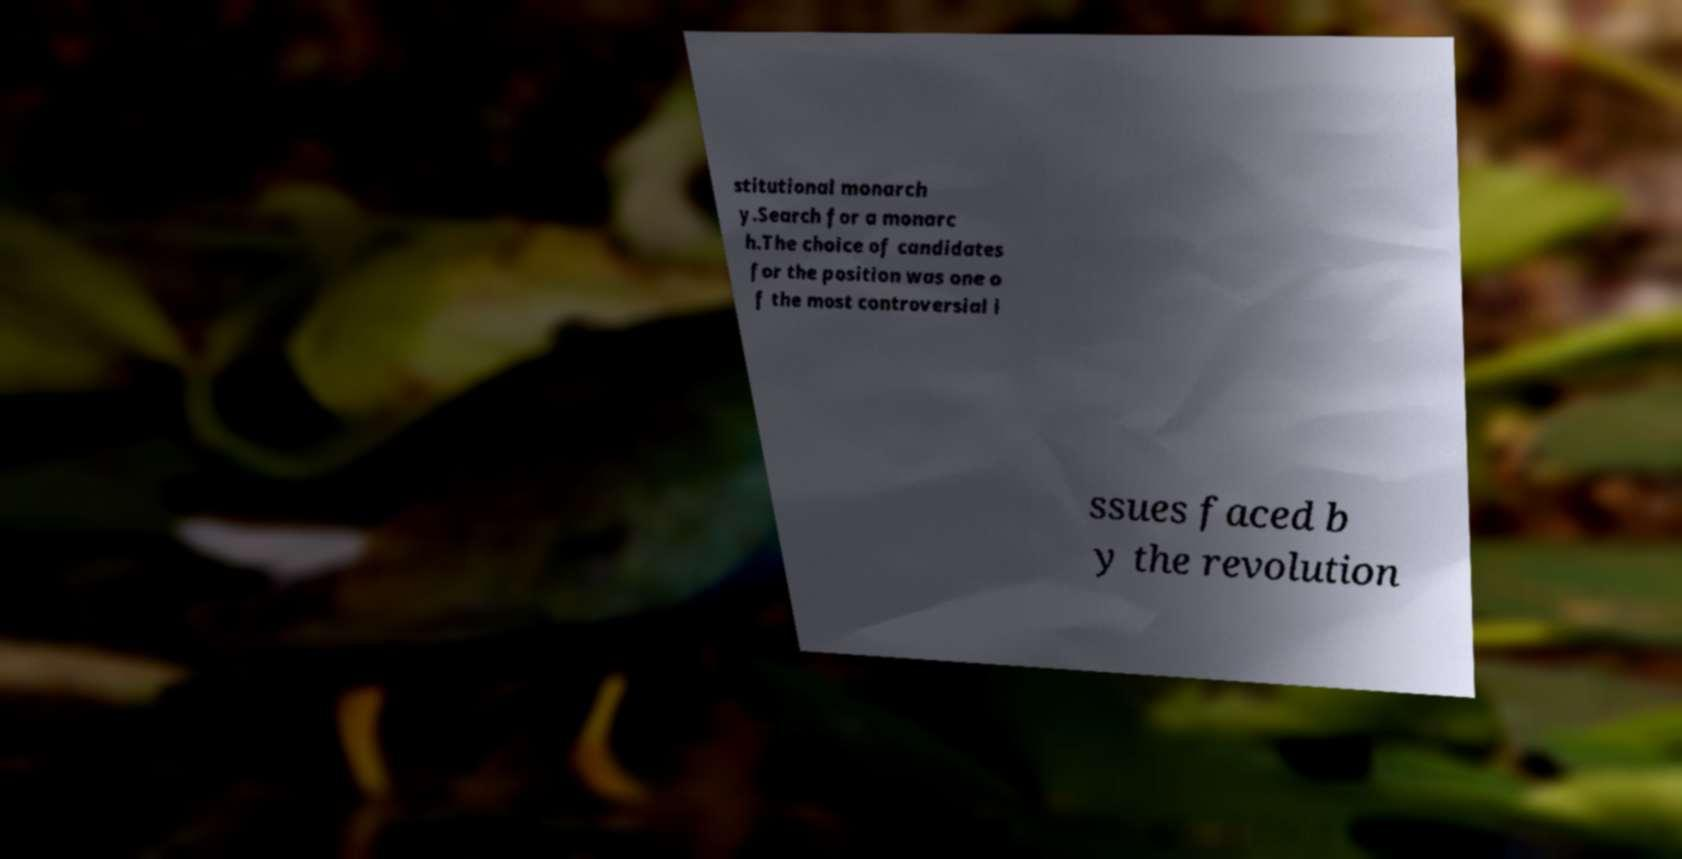Can you accurately transcribe the text from the provided image for me? stitutional monarch y.Search for a monarc h.The choice of candidates for the position was one o f the most controversial i ssues faced b y the revolution 